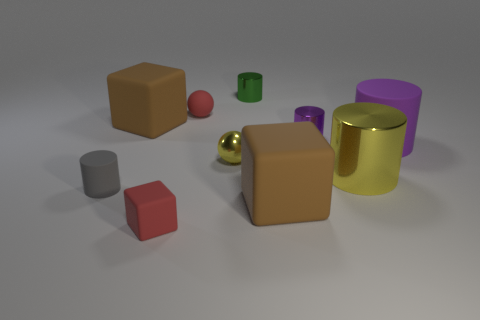Subtract all gray cylinders. How many cylinders are left? 4 Subtract all yellow metallic cylinders. How many cylinders are left? 4 Subtract all cyan spheres. Subtract all gray blocks. How many spheres are left? 2 Subtract all cubes. How many objects are left? 7 Add 5 small purple metallic cylinders. How many small purple metallic cylinders exist? 6 Subtract 1 gray cylinders. How many objects are left? 9 Subtract all small blue metallic cylinders. Subtract all balls. How many objects are left? 8 Add 1 tiny purple shiny things. How many tiny purple shiny things are left? 2 